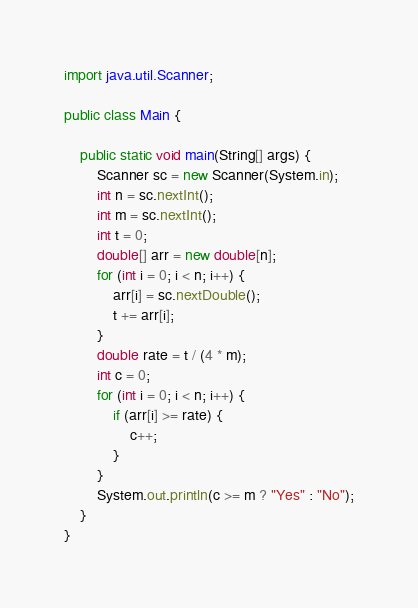Convert code to text. <code><loc_0><loc_0><loc_500><loc_500><_Java_>import java.util.Scanner;

public class Main {

    public static void main(String[] args) {
        Scanner sc = new Scanner(System.in);
        int n = sc.nextInt();
        int m = sc.nextInt();
        int t = 0;
        double[] arr = new double[n];
        for (int i = 0; i < n; i++) {
            arr[i] = sc.nextDouble();
            t += arr[i];
        }
        double rate = t / (4 * m);
        int c = 0;
        for (int i = 0; i < n; i++) {
            if (arr[i] >= rate) {
                c++;
            }
        }
        System.out.println(c >= m ? "Yes" : "No");
    }
}</code> 